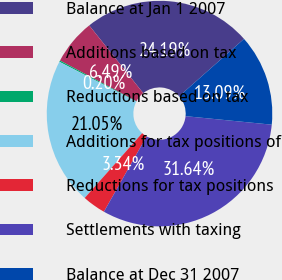Convert chart to OTSL. <chart><loc_0><loc_0><loc_500><loc_500><pie_chart><fcel>Balance at Jan 1 2007<fcel>Additions based on tax<fcel>Reductions based on tax<fcel>Additions for tax positions of<fcel>Reductions for tax positions<fcel>Settlements with taxing<fcel>Balance at Dec 31 2007<nl><fcel>24.19%<fcel>6.49%<fcel>0.2%<fcel>21.05%<fcel>3.34%<fcel>31.64%<fcel>13.09%<nl></chart> 